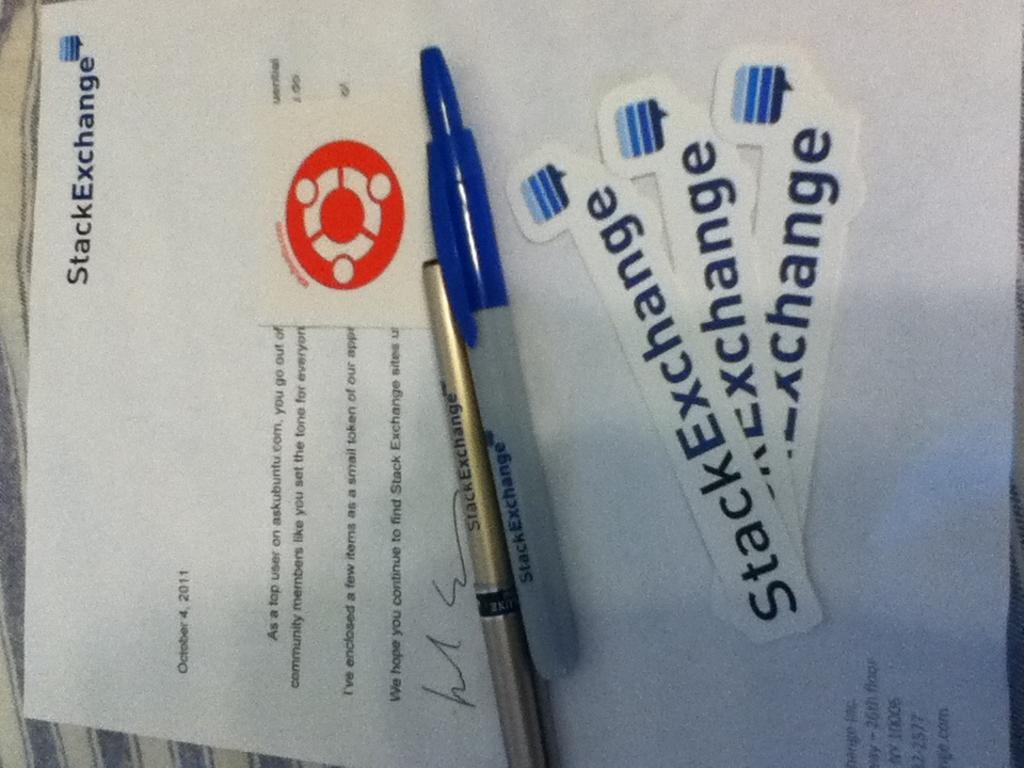Describe this image in one or two sentences. In this image we can see there is a paper with text and a logo. And there are pens. At the back there is a cloth. 